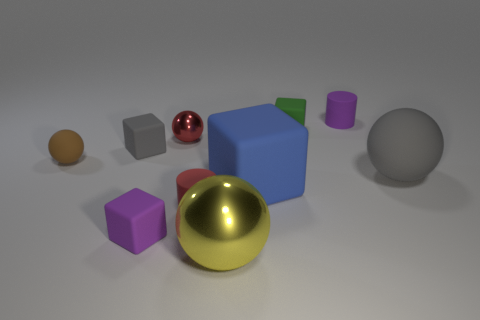Which object in the image seems to be the lightest in weight? Based on the image, the small orange sphere seems to be the lightest in weight due to its size compared to the other objects. 